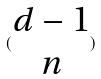<formula> <loc_0><loc_0><loc_500><loc_500>( \begin{matrix} d - 1 \\ n \end{matrix} )</formula> 